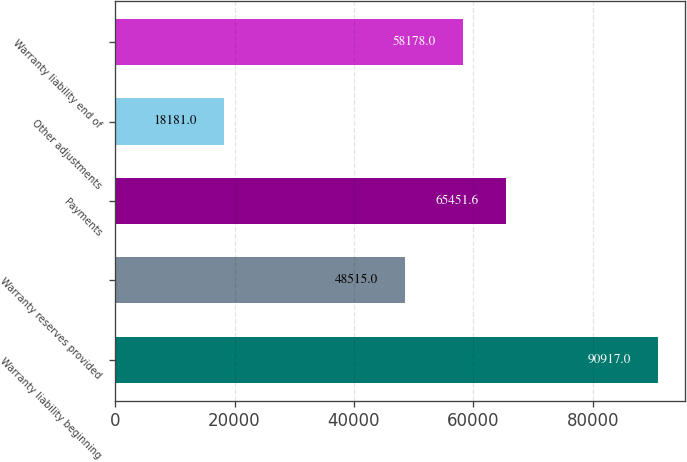Convert chart. <chart><loc_0><loc_0><loc_500><loc_500><bar_chart><fcel>Warranty liability beginning<fcel>Warranty reserves provided<fcel>Payments<fcel>Other adjustments<fcel>Warranty liability end of<nl><fcel>90917<fcel>48515<fcel>65451.6<fcel>18181<fcel>58178<nl></chart> 